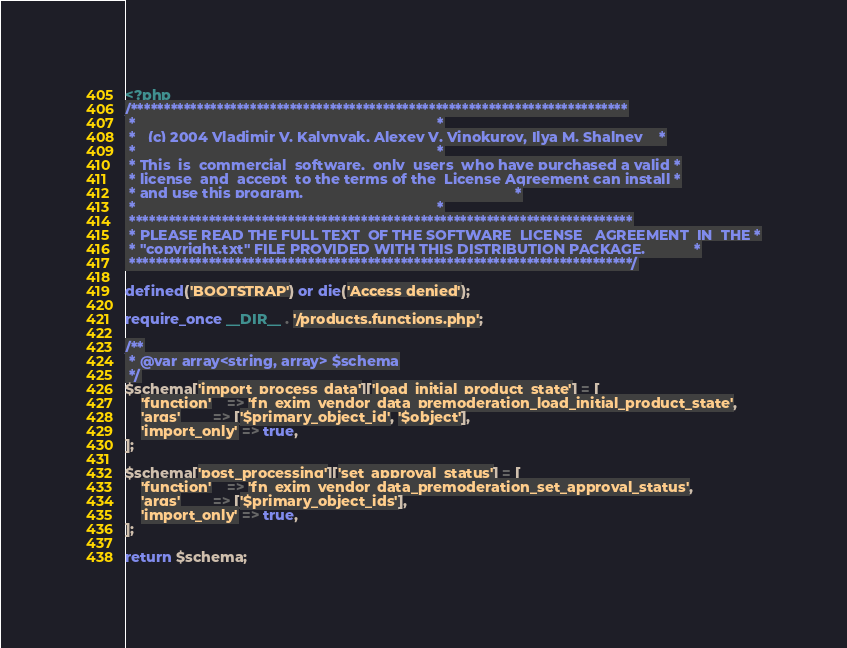<code> <loc_0><loc_0><loc_500><loc_500><_PHP_><?php
/***************************************************************************
 *                                                                          *
 *   (c) 2004 Vladimir V. Kalynyak, Alexey V. Vinokurov, Ilya M. Shalnev    *
 *                                                                          *
 * This  is  commercial  software,  only  users  who have purchased a valid *
 * license  and  accept  to the terms of the  License Agreement can install *
 * and use this program.                                                    *
 *                                                                          *
 ****************************************************************************
 * PLEASE READ THE FULL TEXT  OF THE SOFTWARE  LICENSE   AGREEMENT  IN  THE *
 * "copyright.txt" FILE PROVIDED WITH THIS DISTRIBUTION PACKAGE.            *
 ****************************************************************************/

defined('BOOTSTRAP') or die('Access denied');

require_once __DIR__ . '/products.functions.php';

/**
 * @var array<string, array> $schema
 */
$schema['import_process_data']['load_initial_product_state'] = [
    'function'    => 'fn_exim_vendor_data_premoderation_load_initial_product_state',
    'args'        => ['$primary_object_id', '$object'],
    'import_only' => true,
];

$schema['post_processing']['set_approval_status'] = [
    'function'    => 'fn_exim_vendor_data_premoderation_set_approval_status',
    'args'        => ['$primary_object_ids'],
    'import_only' => true,
];

return $schema;
</code> 